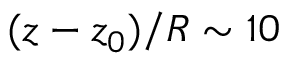<formula> <loc_0><loc_0><loc_500><loc_500>( z - z _ { 0 } ) / R \sim 1 0</formula> 